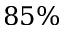<formula> <loc_0><loc_0><loc_500><loc_500>8 5 \%</formula> 